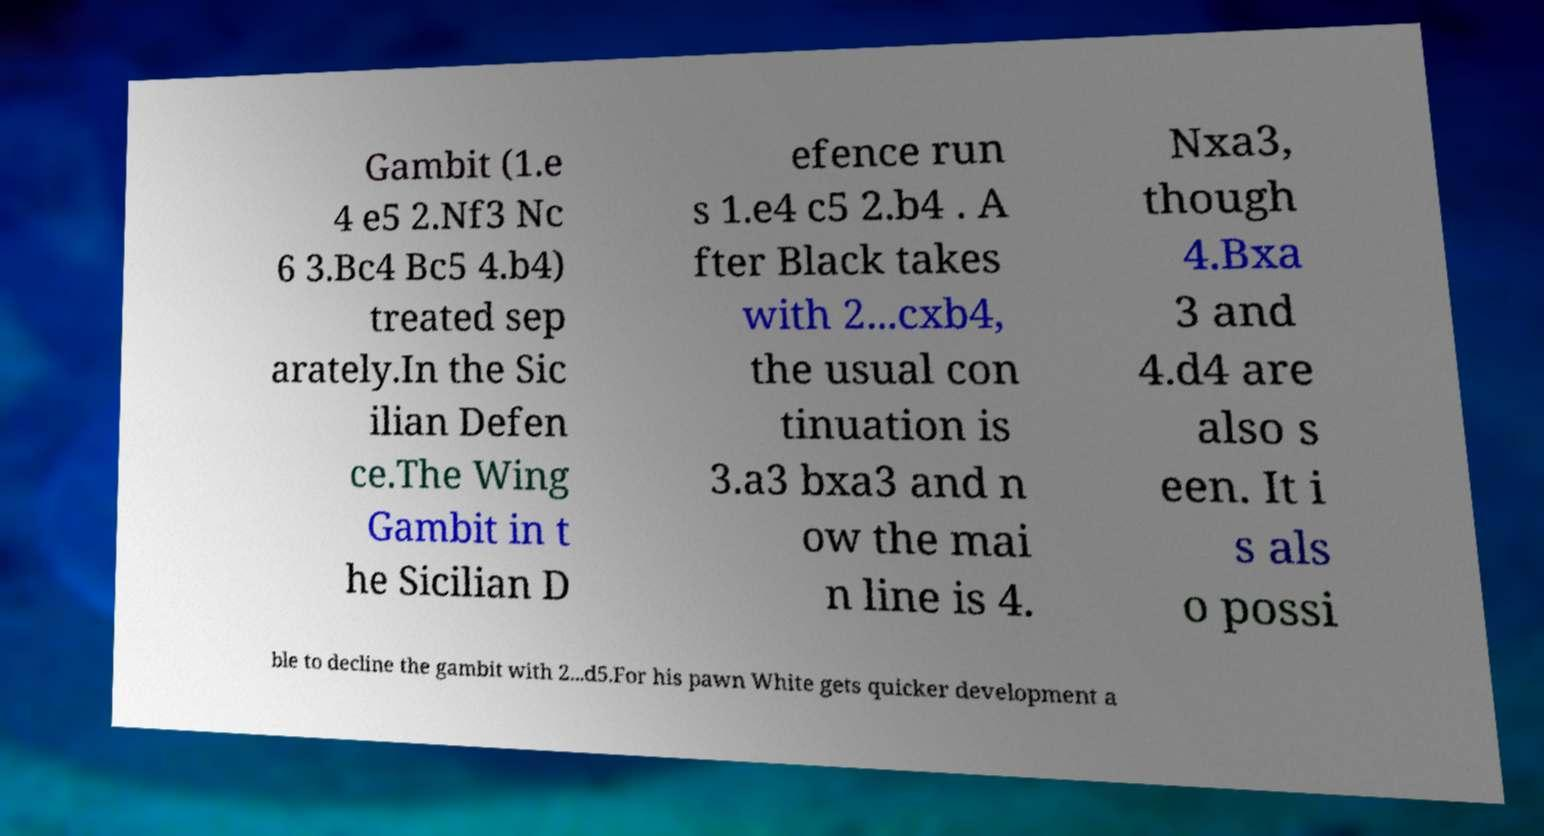I need the written content from this picture converted into text. Can you do that? Gambit (1.e 4 e5 2.Nf3 Nc 6 3.Bc4 Bc5 4.b4) treated sep arately.In the Sic ilian Defen ce.The Wing Gambit in t he Sicilian D efence run s 1.e4 c5 2.b4 . A fter Black takes with 2...cxb4, the usual con tinuation is 3.a3 bxa3 and n ow the mai n line is 4. Nxa3, though 4.Bxa 3 and 4.d4 are also s een. It i s als o possi ble to decline the gambit with 2...d5.For his pawn White gets quicker development a 